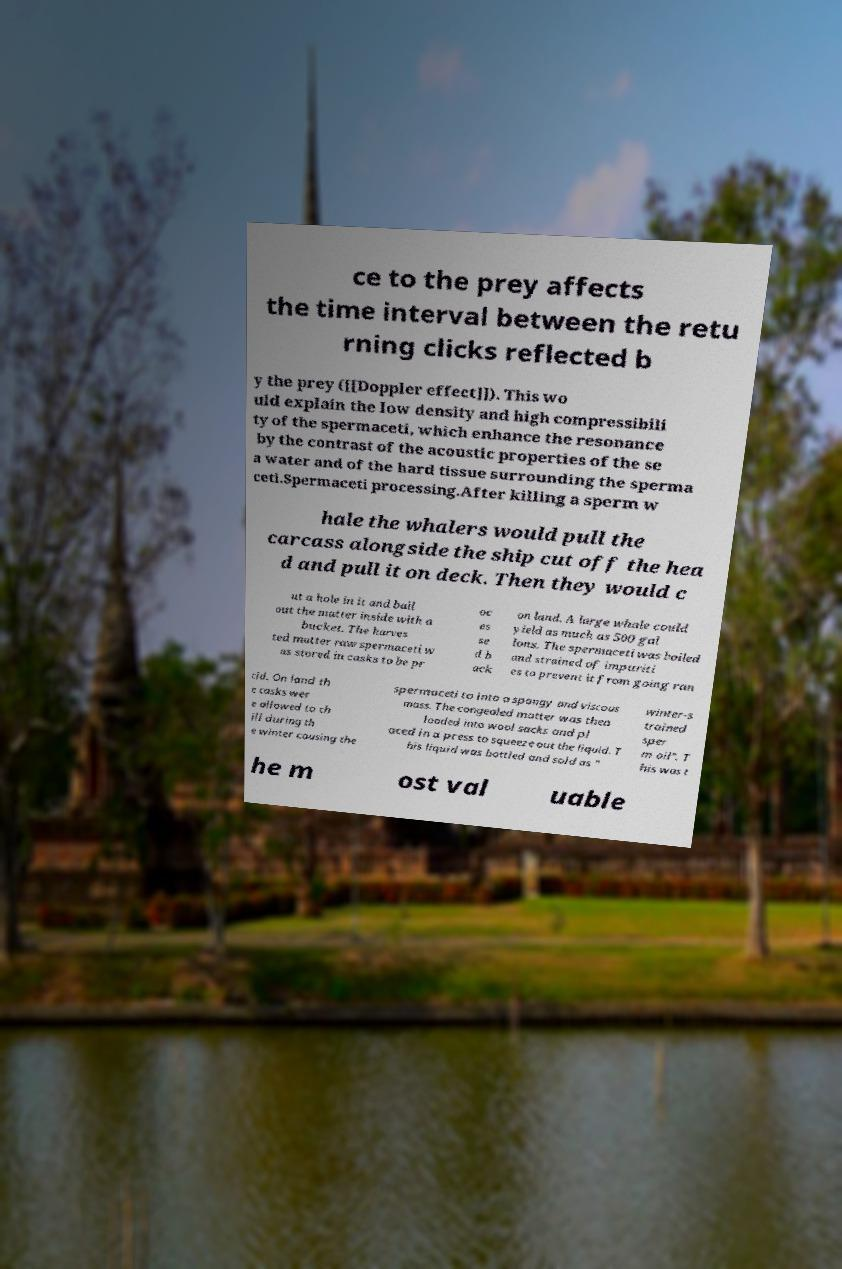There's text embedded in this image that I need extracted. Can you transcribe it verbatim? ce to the prey affects the time interval between the retu rning clicks reflected b y the prey ([[Doppler effect]]). This wo uld explain the low density and high compressibili ty of the spermaceti, which enhance the resonance by the contrast of the acoustic properties of the se a water and of the hard tissue surrounding the sperma ceti.Spermaceti processing.After killing a sperm w hale the whalers would pull the carcass alongside the ship cut off the hea d and pull it on deck. Then they would c ut a hole in it and bail out the matter inside with a bucket. The harves ted matter raw spermaceti w as stored in casks to be pr oc es se d b ack on land. A large whale could yield as much as 500 gal lons. The spermaceti was boiled and strained of impuriti es to prevent it from going ran cid. On land th e casks wer e allowed to ch ill during th e winter causing the spermaceti to into a spongy and viscous mass. The congealed matter was then loaded into wool sacks and pl aced in a press to squeeze out the liquid. T his liquid was bottled and sold as " winter-s trained sper m oil". T his was t he m ost val uable 